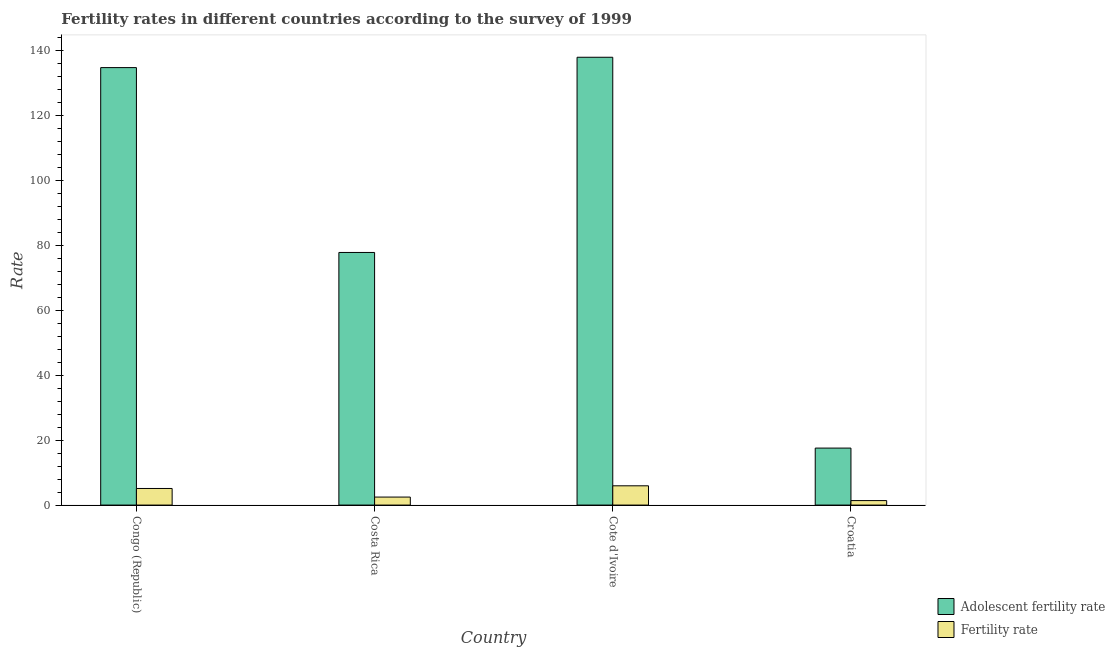Are the number of bars on each tick of the X-axis equal?
Keep it short and to the point. Yes. How many bars are there on the 3rd tick from the right?
Your answer should be very brief. 2. What is the label of the 4th group of bars from the left?
Provide a short and direct response. Croatia. In how many cases, is the number of bars for a given country not equal to the number of legend labels?
Give a very brief answer. 0. What is the adolescent fertility rate in Cote d'Ivoire?
Provide a short and direct response. 137.95. Across all countries, what is the maximum adolescent fertility rate?
Your response must be concise. 137.95. Across all countries, what is the minimum fertility rate?
Your response must be concise. 1.38. In which country was the fertility rate maximum?
Provide a short and direct response. Cote d'Ivoire. In which country was the fertility rate minimum?
Offer a very short reply. Croatia. What is the total fertility rate in the graph?
Provide a succinct answer. 14.89. What is the difference between the adolescent fertility rate in Costa Rica and that in Cote d'Ivoire?
Your answer should be very brief. -60.13. What is the difference between the fertility rate in Croatia and the adolescent fertility rate in Costa Rica?
Provide a succinct answer. -76.44. What is the average fertility rate per country?
Provide a succinct answer. 3.72. What is the difference between the fertility rate and adolescent fertility rate in Costa Rica?
Ensure brevity in your answer.  -75.36. In how many countries, is the fertility rate greater than 56 ?
Give a very brief answer. 0. What is the ratio of the fertility rate in Congo (Republic) to that in Costa Rica?
Provide a short and direct response. 2.08. Is the fertility rate in Cote d'Ivoire less than that in Croatia?
Offer a terse response. No. Is the difference between the adolescent fertility rate in Congo (Republic) and Croatia greater than the difference between the fertility rate in Congo (Republic) and Croatia?
Ensure brevity in your answer.  Yes. What is the difference between the highest and the second highest fertility rate?
Provide a short and direct response. 0.82. What is the difference between the highest and the lowest fertility rate?
Make the answer very short. 4.55. In how many countries, is the fertility rate greater than the average fertility rate taken over all countries?
Provide a succinct answer. 2. Is the sum of the fertility rate in Costa Rica and Cote d'Ivoire greater than the maximum adolescent fertility rate across all countries?
Offer a very short reply. No. What does the 1st bar from the left in Costa Rica represents?
Your answer should be compact. Adolescent fertility rate. What does the 2nd bar from the right in Costa Rica represents?
Make the answer very short. Adolescent fertility rate. Are all the bars in the graph horizontal?
Your answer should be compact. No. How many countries are there in the graph?
Provide a short and direct response. 4. What is the difference between two consecutive major ticks on the Y-axis?
Make the answer very short. 20. Does the graph contain any zero values?
Ensure brevity in your answer.  No. Does the graph contain grids?
Provide a succinct answer. No. Where does the legend appear in the graph?
Keep it short and to the point. Bottom right. What is the title of the graph?
Keep it short and to the point. Fertility rates in different countries according to the survey of 1999. Does "Overweight" appear as one of the legend labels in the graph?
Your answer should be very brief. No. What is the label or title of the Y-axis?
Keep it short and to the point. Rate. What is the Rate of Adolescent fertility rate in Congo (Republic)?
Your answer should be compact. 134.76. What is the Rate in Fertility rate in Congo (Republic)?
Provide a short and direct response. 5.11. What is the Rate of Adolescent fertility rate in Costa Rica?
Provide a succinct answer. 77.82. What is the Rate in Fertility rate in Costa Rica?
Offer a terse response. 2.46. What is the Rate of Adolescent fertility rate in Cote d'Ivoire?
Your answer should be compact. 137.95. What is the Rate of Fertility rate in Cote d'Ivoire?
Make the answer very short. 5.93. What is the Rate in Adolescent fertility rate in Croatia?
Offer a terse response. 17.55. What is the Rate of Fertility rate in Croatia?
Offer a terse response. 1.38. Across all countries, what is the maximum Rate in Adolescent fertility rate?
Offer a terse response. 137.95. Across all countries, what is the maximum Rate in Fertility rate?
Provide a short and direct response. 5.93. Across all countries, what is the minimum Rate in Adolescent fertility rate?
Keep it short and to the point. 17.55. Across all countries, what is the minimum Rate of Fertility rate?
Keep it short and to the point. 1.38. What is the total Rate in Adolescent fertility rate in the graph?
Ensure brevity in your answer.  368.09. What is the total Rate in Fertility rate in the graph?
Give a very brief answer. 14.89. What is the difference between the Rate in Adolescent fertility rate in Congo (Republic) and that in Costa Rica?
Keep it short and to the point. 56.94. What is the difference between the Rate of Fertility rate in Congo (Republic) and that in Costa Rica?
Keep it short and to the point. 2.65. What is the difference between the Rate in Adolescent fertility rate in Congo (Republic) and that in Cote d'Ivoire?
Your answer should be compact. -3.19. What is the difference between the Rate in Fertility rate in Congo (Republic) and that in Cote d'Ivoire?
Provide a short and direct response. -0.82. What is the difference between the Rate of Adolescent fertility rate in Congo (Republic) and that in Croatia?
Keep it short and to the point. 117.21. What is the difference between the Rate in Fertility rate in Congo (Republic) and that in Croatia?
Your answer should be compact. 3.73. What is the difference between the Rate of Adolescent fertility rate in Costa Rica and that in Cote d'Ivoire?
Offer a very short reply. -60.13. What is the difference between the Rate of Fertility rate in Costa Rica and that in Cote d'Ivoire?
Ensure brevity in your answer.  -3.47. What is the difference between the Rate in Adolescent fertility rate in Costa Rica and that in Croatia?
Ensure brevity in your answer.  60.27. What is the difference between the Rate in Fertility rate in Costa Rica and that in Croatia?
Your response must be concise. 1.08. What is the difference between the Rate in Adolescent fertility rate in Cote d'Ivoire and that in Croatia?
Give a very brief answer. 120.4. What is the difference between the Rate of Fertility rate in Cote d'Ivoire and that in Croatia?
Provide a succinct answer. 4.55. What is the difference between the Rate in Adolescent fertility rate in Congo (Republic) and the Rate in Fertility rate in Costa Rica?
Provide a succinct answer. 132.3. What is the difference between the Rate in Adolescent fertility rate in Congo (Republic) and the Rate in Fertility rate in Cote d'Ivoire?
Ensure brevity in your answer.  128.83. What is the difference between the Rate of Adolescent fertility rate in Congo (Republic) and the Rate of Fertility rate in Croatia?
Make the answer very short. 133.38. What is the difference between the Rate of Adolescent fertility rate in Costa Rica and the Rate of Fertility rate in Cote d'Ivoire?
Give a very brief answer. 71.89. What is the difference between the Rate in Adolescent fertility rate in Costa Rica and the Rate in Fertility rate in Croatia?
Provide a succinct answer. 76.44. What is the difference between the Rate of Adolescent fertility rate in Cote d'Ivoire and the Rate of Fertility rate in Croatia?
Your response must be concise. 136.57. What is the average Rate in Adolescent fertility rate per country?
Offer a terse response. 92.02. What is the average Rate in Fertility rate per country?
Your answer should be very brief. 3.72. What is the difference between the Rate in Adolescent fertility rate and Rate in Fertility rate in Congo (Republic)?
Offer a terse response. 129.65. What is the difference between the Rate of Adolescent fertility rate and Rate of Fertility rate in Costa Rica?
Your answer should be compact. 75.36. What is the difference between the Rate of Adolescent fertility rate and Rate of Fertility rate in Cote d'Ivoire?
Offer a very short reply. 132.01. What is the difference between the Rate of Adolescent fertility rate and Rate of Fertility rate in Croatia?
Ensure brevity in your answer.  16.17. What is the ratio of the Rate in Adolescent fertility rate in Congo (Republic) to that in Costa Rica?
Provide a succinct answer. 1.73. What is the ratio of the Rate of Fertility rate in Congo (Republic) to that in Costa Rica?
Keep it short and to the point. 2.08. What is the ratio of the Rate of Adolescent fertility rate in Congo (Republic) to that in Cote d'Ivoire?
Provide a short and direct response. 0.98. What is the ratio of the Rate of Fertility rate in Congo (Republic) to that in Cote d'Ivoire?
Your answer should be compact. 0.86. What is the ratio of the Rate of Adolescent fertility rate in Congo (Republic) to that in Croatia?
Give a very brief answer. 7.68. What is the ratio of the Rate in Fertility rate in Congo (Republic) to that in Croatia?
Provide a short and direct response. 3.71. What is the ratio of the Rate of Adolescent fertility rate in Costa Rica to that in Cote d'Ivoire?
Provide a succinct answer. 0.56. What is the ratio of the Rate in Fertility rate in Costa Rica to that in Cote d'Ivoire?
Your response must be concise. 0.41. What is the ratio of the Rate of Adolescent fertility rate in Costa Rica to that in Croatia?
Offer a very short reply. 4.43. What is the ratio of the Rate in Fertility rate in Costa Rica to that in Croatia?
Provide a short and direct response. 1.78. What is the ratio of the Rate of Adolescent fertility rate in Cote d'Ivoire to that in Croatia?
Your answer should be compact. 7.86. What is the ratio of the Rate of Fertility rate in Cote d'Ivoire to that in Croatia?
Offer a terse response. 4.3. What is the difference between the highest and the second highest Rate of Adolescent fertility rate?
Provide a short and direct response. 3.19. What is the difference between the highest and the second highest Rate in Fertility rate?
Offer a terse response. 0.82. What is the difference between the highest and the lowest Rate in Adolescent fertility rate?
Your answer should be compact. 120.4. What is the difference between the highest and the lowest Rate of Fertility rate?
Offer a very short reply. 4.55. 